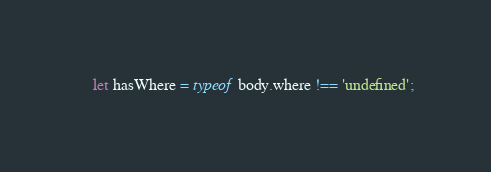<code> <loc_0><loc_0><loc_500><loc_500><_JavaScript_>    let hasWhere = typeof body.where !== 'undefined';</code> 